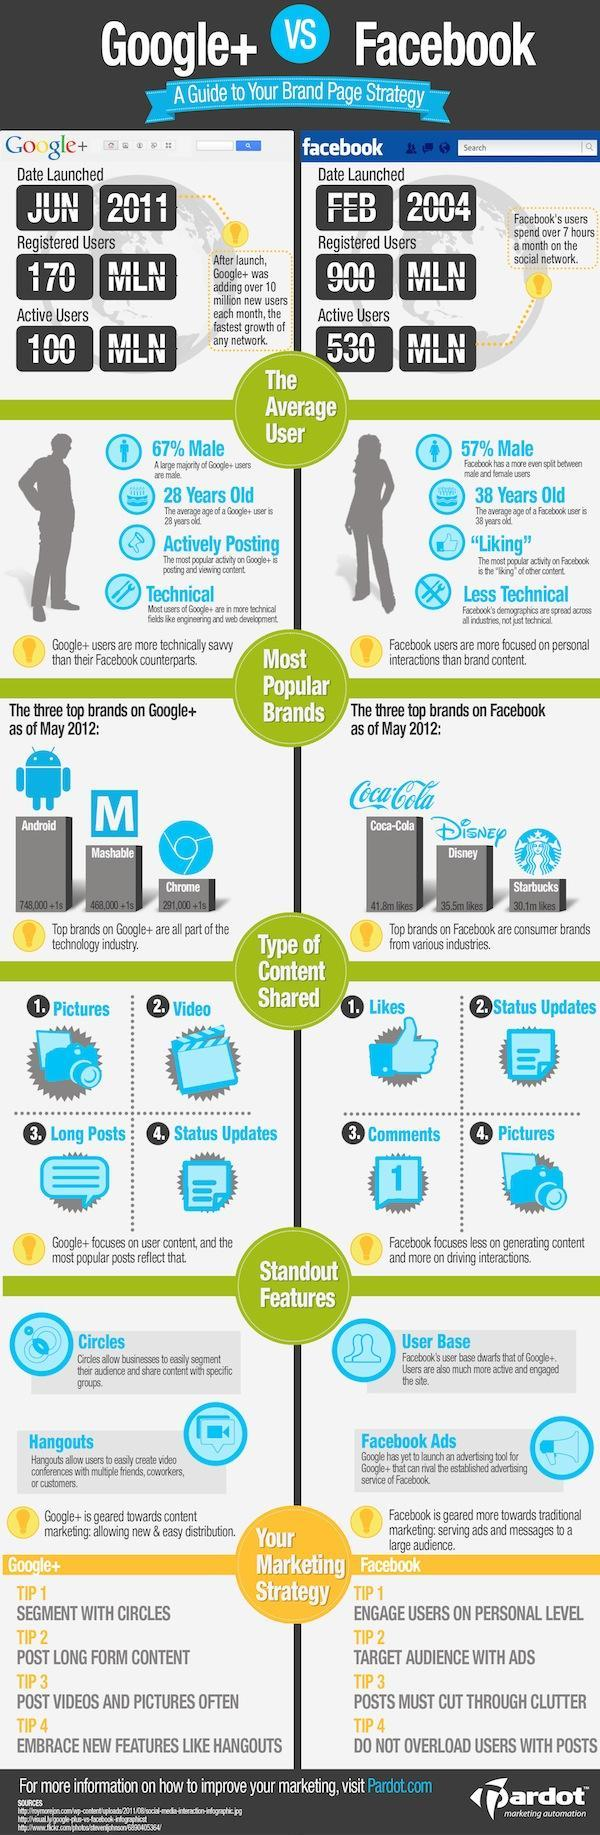What are the attributes of Facebook?
Answer the question with a short phrase. User Base, Facebook ads Which month was Facebook launched, January, February, or June? February What percentage of male users use Google + more than Facebook? 10% What is the percentage of female users using Facebook? 43% Which types of content can be shared commonly on both Google+ and Facebook? Pictures, Status Updates What are the highlights of Google+ ? Circles, Hangouts What is the difference in the number of people using Google+ and Facebook actively? 430 MLN How much more users does Facebook have in comparison to Google +? 730 MLN Which is the most popular brand in Facebook, Starbucks, Disney, or Coca-Cola? Coca-Cola Which of these three brands is second most popular in Google +, Mashable, Chrome, or Android? Mashable 